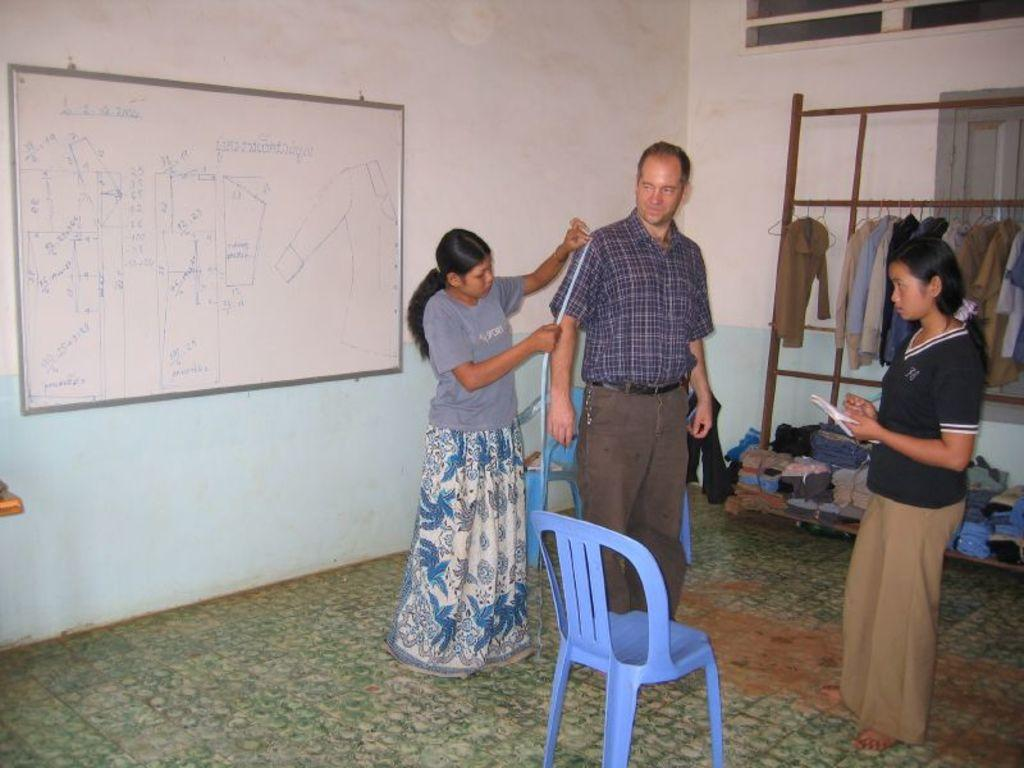How many people are in the image? There are three people in the image. Can you describe the gender of the people in the image? Two of the people are women, and one is a man. Where are the people located in the image? The people are standing on the floor. What is the purpose of the whiteboard in the image? The whiteboard's purpose is not specified, but it is likely used for writing or displaying information. What type of furniture is present in the image? There are chairs in the image. What type of yarn is being used to create the question on the whiteboard? There is no yarn present in the image, and the whiteboard does not contain a question. 